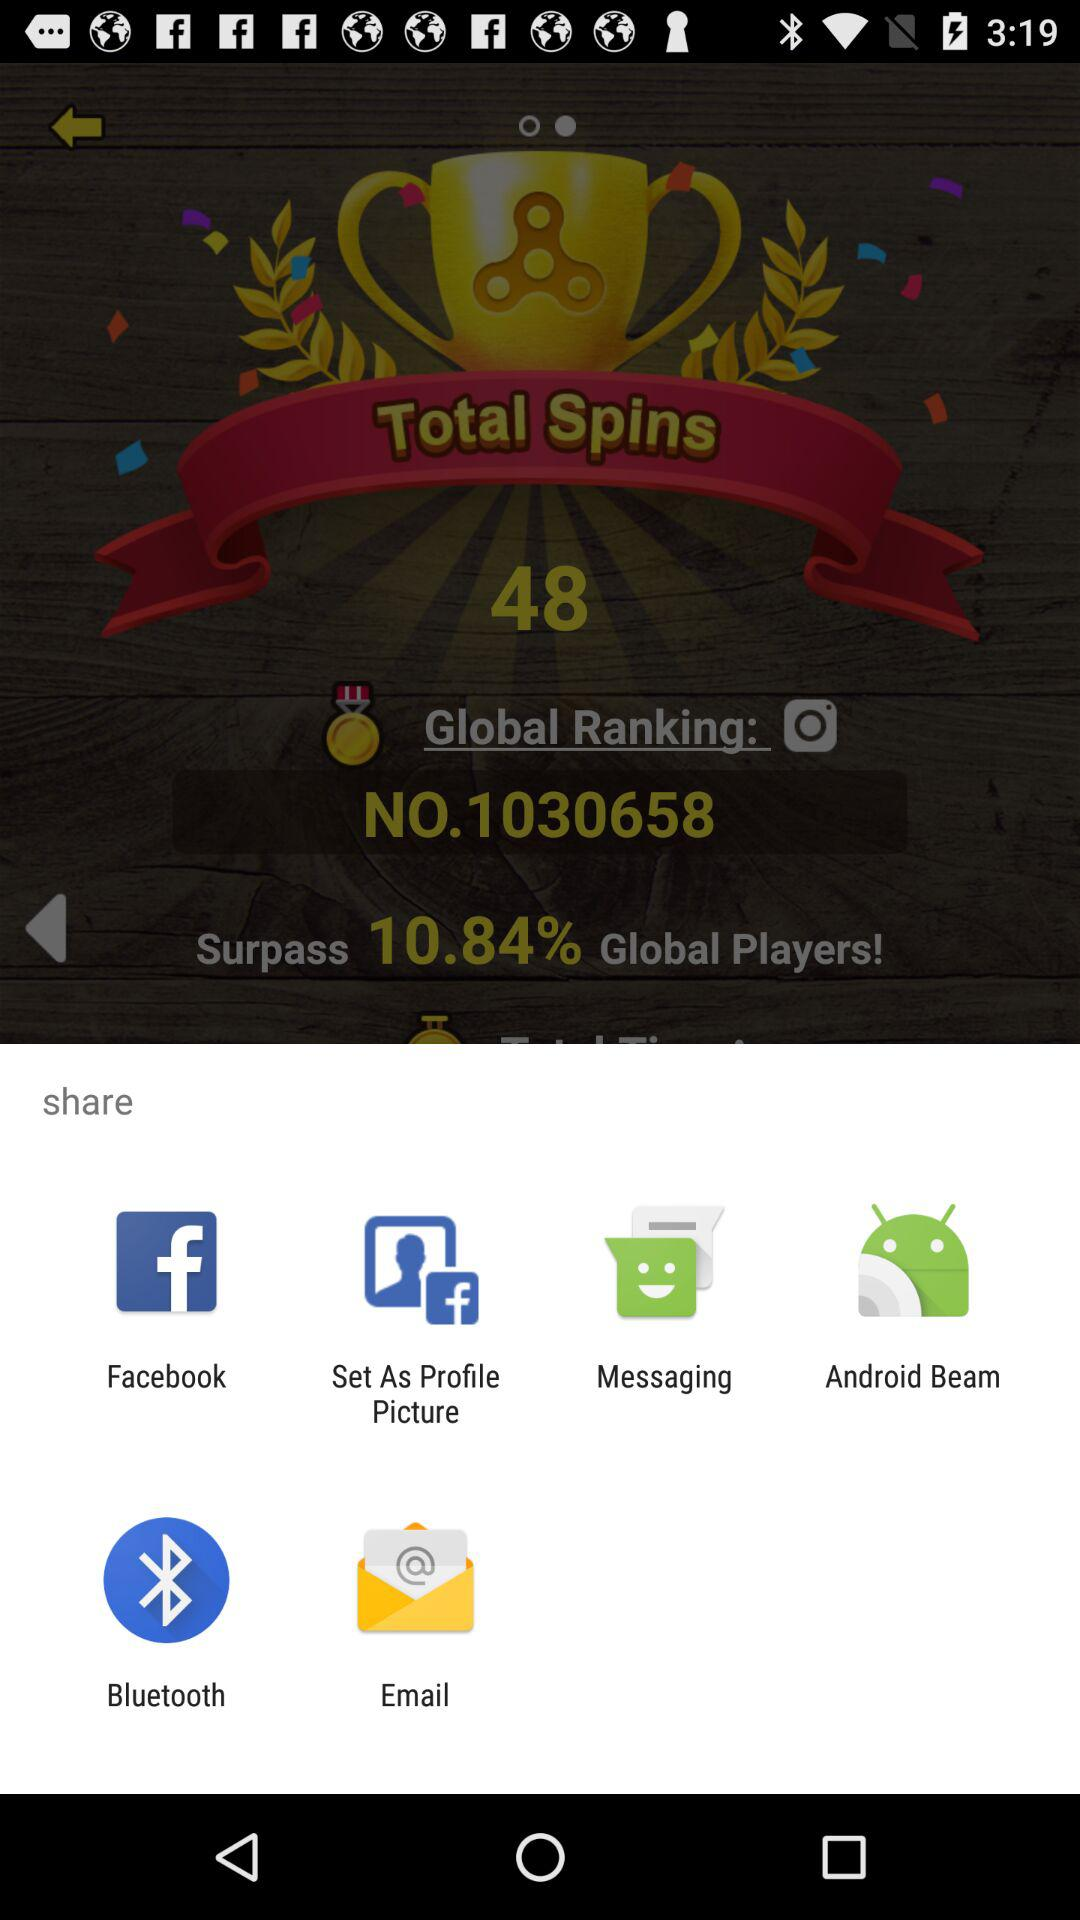What are the sharing options? The sharing options are "Facebook", "Set As Profile Picture", "Messaging", "Android Beam", "Bluetooth" and "Email". 